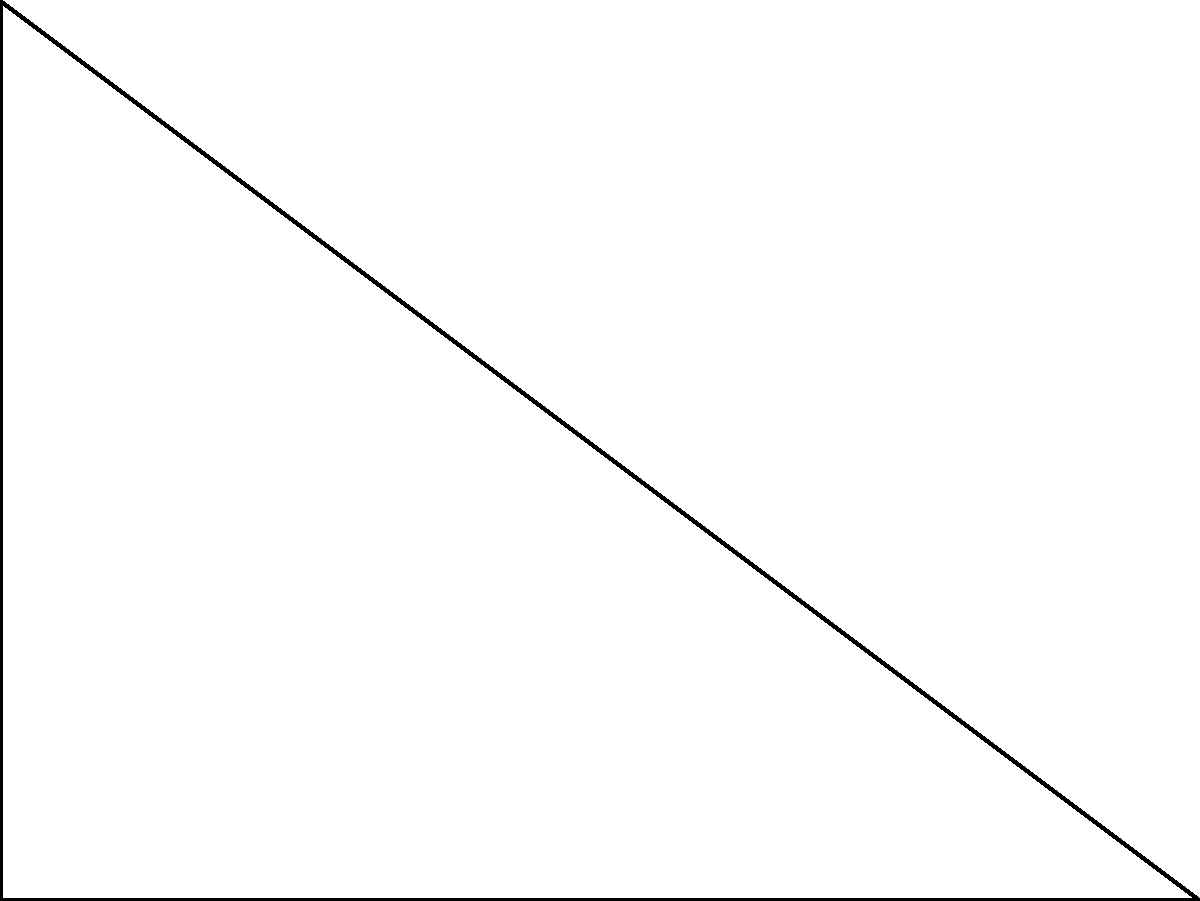As a member of the National Council of Jewish Women (NCJW) organizing a community service project to improve accessibility, you're tasked with designing a ramp for a local synagogue. The ramp needs to reach a height of 3 feet over a horizontal distance of 4 feet. To maximize accessibility while minimizing the ramp's length, you need to determine the optimal angle $\theta$ for the ramp. Using calculus, find the angle $\theta$ that minimizes the length of the ramp $L$. Let's approach this step-by-step:

1) First, we need to express the length of the ramp $L$ in terms of $\theta$. From the right triangle:

   $\tan\theta = \frac{3}{4}$
   $\sec\theta = \frac{L}{4}$

2) We want to minimize $L$. Since $L = 4\sec\theta$, minimizing $L$ is equivalent to minimizing $\sec\theta$.

3) To find the minimum, we need to differentiate $\sec\theta$ with respect to $\theta$ and set it to zero:

   $\frac{d}{d\theta}(\sec\theta) = \sec\theta\tan\theta = 0$

4) This equation is satisfied when $\tan\theta = 0$ (which doesn't apply here as the ramp needs to rise), or when $\sec\theta = 0$ (which is impossible). Therefore, we don't have a local minimum or maximum.

5) However, we know that $\tan\theta = \frac{3}{4}$ is a constraint of our problem. Let's use this:

   $\sec^2\theta = 1 + \tan^2\theta = 1 + (\frac{3}{4})^2 = \frac{25}{16}$

6) Therefore, $\sec\theta = \frac{5}{4}$

7) The optimal angle is thus:

   $\theta = \arccos(\frac{4}{5}) \approx 36.87°$

This angle provides the shortest ramp length while meeting the height requirement, optimizing accessibility for the synagogue.
Answer: $\theta = \arccos(\frac{4}{5}) \approx 36.87°$ 